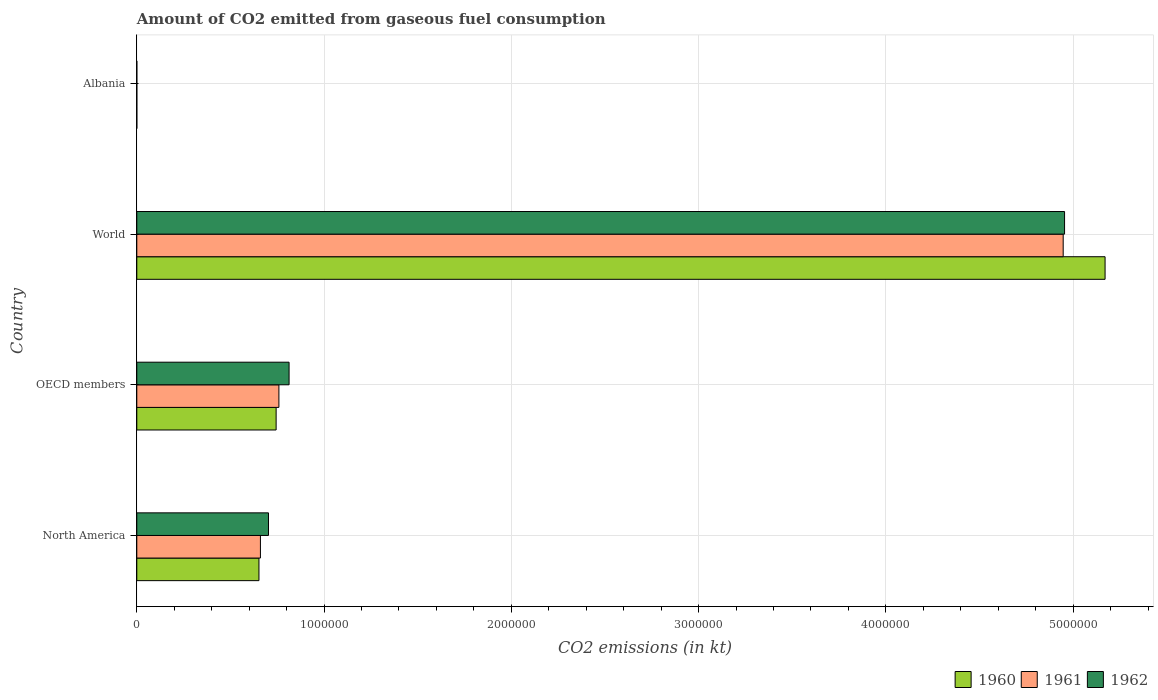How many different coloured bars are there?
Keep it short and to the point. 3. Are the number of bars per tick equal to the number of legend labels?
Give a very brief answer. Yes. What is the amount of CO2 emitted in 1962 in OECD members?
Provide a short and direct response. 8.13e+05. Across all countries, what is the maximum amount of CO2 emitted in 1962?
Give a very brief answer. 4.95e+06. Across all countries, what is the minimum amount of CO2 emitted in 1960?
Offer a very short reply. 84.34. In which country was the amount of CO2 emitted in 1960 minimum?
Offer a very short reply. Albania. What is the total amount of CO2 emitted in 1961 in the graph?
Your answer should be very brief. 6.37e+06. What is the difference between the amount of CO2 emitted in 1962 in Albania and that in OECD members?
Provide a short and direct response. -8.13e+05. What is the difference between the amount of CO2 emitted in 1960 in Albania and the amount of CO2 emitted in 1962 in North America?
Your answer should be very brief. -7.03e+05. What is the average amount of CO2 emitted in 1961 per country?
Make the answer very short. 1.59e+06. What is the difference between the amount of CO2 emitted in 1962 and amount of CO2 emitted in 1961 in North America?
Offer a terse response. 4.30e+04. What is the ratio of the amount of CO2 emitted in 1960 in Albania to that in North America?
Offer a very short reply. 0. Is the difference between the amount of CO2 emitted in 1962 in Albania and World greater than the difference between the amount of CO2 emitted in 1961 in Albania and World?
Ensure brevity in your answer.  No. What is the difference between the highest and the second highest amount of CO2 emitted in 1960?
Ensure brevity in your answer.  4.43e+06. What is the difference between the highest and the lowest amount of CO2 emitted in 1962?
Provide a succinct answer. 4.95e+06. What does the 3rd bar from the top in World represents?
Provide a short and direct response. 1960. What does the 2nd bar from the bottom in World represents?
Keep it short and to the point. 1961. How many bars are there?
Your response must be concise. 12. Are all the bars in the graph horizontal?
Your response must be concise. Yes. What is the difference between two consecutive major ticks on the X-axis?
Provide a short and direct response. 1.00e+06. Are the values on the major ticks of X-axis written in scientific E-notation?
Make the answer very short. No. Where does the legend appear in the graph?
Your answer should be compact. Bottom right. How many legend labels are there?
Offer a terse response. 3. How are the legend labels stacked?
Give a very brief answer. Horizontal. What is the title of the graph?
Your answer should be very brief. Amount of CO2 emitted from gaseous fuel consumption. Does "2014" appear as one of the legend labels in the graph?
Provide a short and direct response. No. What is the label or title of the X-axis?
Your answer should be very brief. CO2 emissions (in kt). What is the CO2 emissions (in kt) of 1960 in North America?
Provide a short and direct response. 6.52e+05. What is the CO2 emissions (in kt) of 1961 in North America?
Provide a succinct answer. 6.60e+05. What is the CO2 emissions (in kt) of 1962 in North America?
Ensure brevity in your answer.  7.03e+05. What is the CO2 emissions (in kt) in 1960 in OECD members?
Your response must be concise. 7.44e+05. What is the CO2 emissions (in kt) of 1961 in OECD members?
Ensure brevity in your answer.  7.59e+05. What is the CO2 emissions (in kt) in 1962 in OECD members?
Make the answer very short. 8.13e+05. What is the CO2 emissions (in kt) in 1960 in World?
Ensure brevity in your answer.  5.17e+06. What is the CO2 emissions (in kt) in 1961 in World?
Your answer should be compact. 4.95e+06. What is the CO2 emissions (in kt) of 1962 in World?
Make the answer very short. 4.95e+06. What is the CO2 emissions (in kt) of 1960 in Albania?
Your response must be concise. 84.34. What is the CO2 emissions (in kt) of 1961 in Albania?
Your answer should be compact. 84.34. What is the CO2 emissions (in kt) in 1962 in Albania?
Provide a succinct answer. 84.34. Across all countries, what is the maximum CO2 emissions (in kt) of 1960?
Provide a succinct answer. 5.17e+06. Across all countries, what is the maximum CO2 emissions (in kt) of 1961?
Make the answer very short. 4.95e+06. Across all countries, what is the maximum CO2 emissions (in kt) in 1962?
Ensure brevity in your answer.  4.95e+06. Across all countries, what is the minimum CO2 emissions (in kt) of 1960?
Keep it short and to the point. 84.34. Across all countries, what is the minimum CO2 emissions (in kt) of 1961?
Ensure brevity in your answer.  84.34. Across all countries, what is the minimum CO2 emissions (in kt) of 1962?
Give a very brief answer. 84.34. What is the total CO2 emissions (in kt) of 1960 in the graph?
Your answer should be compact. 6.57e+06. What is the total CO2 emissions (in kt) of 1961 in the graph?
Provide a succinct answer. 6.37e+06. What is the total CO2 emissions (in kt) in 1962 in the graph?
Keep it short and to the point. 6.47e+06. What is the difference between the CO2 emissions (in kt) in 1960 in North America and that in OECD members?
Keep it short and to the point. -9.17e+04. What is the difference between the CO2 emissions (in kt) of 1961 in North America and that in OECD members?
Your answer should be compact. -9.86e+04. What is the difference between the CO2 emissions (in kt) of 1962 in North America and that in OECD members?
Provide a short and direct response. -1.10e+05. What is the difference between the CO2 emissions (in kt) in 1960 in North America and that in World?
Ensure brevity in your answer.  -4.52e+06. What is the difference between the CO2 emissions (in kt) in 1961 in North America and that in World?
Your answer should be compact. -4.29e+06. What is the difference between the CO2 emissions (in kt) of 1962 in North America and that in World?
Keep it short and to the point. -4.25e+06. What is the difference between the CO2 emissions (in kt) in 1960 in North America and that in Albania?
Your response must be concise. 6.52e+05. What is the difference between the CO2 emissions (in kt) in 1961 in North America and that in Albania?
Offer a very short reply. 6.60e+05. What is the difference between the CO2 emissions (in kt) of 1962 in North America and that in Albania?
Make the answer very short. 7.03e+05. What is the difference between the CO2 emissions (in kt) in 1960 in OECD members and that in World?
Keep it short and to the point. -4.43e+06. What is the difference between the CO2 emissions (in kt) of 1961 in OECD members and that in World?
Provide a succinct answer. -4.19e+06. What is the difference between the CO2 emissions (in kt) in 1962 in OECD members and that in World?
Give a very brief answer. -4.14e+06. What is the difference between the CO2 emissions (in kt) of 1960 in OECD members and that in Albania?
Provide a short and direct response. 7.44e+05. What is the difference between the CO2 emissions (in kt) in 1961 in OECD members and that in Albania?
Give a very brief answer. 7.59e+05. What is the difference between the CO2 emissions (in kt) of 1962 in OECD members and that in Albania?
Ensure brevity in your answer.  8.13e+05. What is the difference between the CO2 emissions (in kt) in 1960 in World and that in Albania?
Your response must be concise. 5.17e+06. What is the difference between the CO2 emissions (in kt) in 1961 in World and that in Albania?
Give a very brief answer. 4.95e+06. What is the difference between the CO2 emissions (in kt) in 1962 in World and that in Albania?
Make the answer very short. 4.95e+06. What is the difference between the CO2 emissions (in kt) of 1960 in North America and the CO2 emissions (in kt) of 1961 in OECD members?
Your answer should be compact. -1.06e+05. What is the difference between the CO2 emissions (in kt) in 1960 in North America and the CO2 emissions (in kt) in 1962 in OECD members?
Keep it short and to the point. -1.61e+05. What is the difference between the CO2 emissions (in kt) of 1961 in North America and the CO2 emissions (in kt) of 1962 in OECD members?
Offer a terse response. -1.53e+05. What is the difference between the CO2 emissions (in kt) in 1960 in North America and the CO2 emissions (in kt) in 1961 in World?
Provide a succinct answer. -4.29e+06. What is the difference between the CO2 emissions (in kt) in 1960 in North America and the CO2 emissions (in kt) in 1962 in World?
Provide a short and direct response. -4.30e+06. What is the difference between the CO2 emissions (in kt) in 1961 in North America and the CO2 emissions (in kt) in 1962 in World?
Make the answer very short. -4.29e+06. What is the difference between the CO2 emissions (in kt) of 1960 in North America and the CO2 emissions (in kt) of 1961 in Albania?
Offer a terse response. 6.52e+05. What is the difference between the CO2 emissions (in kt) in 1960 in North America and the CO2 emissions (in kt) in 1962 in Albania?
Keep it short and to the point. 6.52e+05. What is the difference between the CO2 emissions (in kt) of 1961 in North America and the CO2 emissions (in kt) of 1962 in Albania?
Offer a very short reply. 6.60e+05. What is the difference between the CO2 emissions (in kt) of 1960 in OECD members and the CO2 emissions (in kt) of 1961 in World?
Keep it short and to the point. -4.20e+06. What is the difference between the CO2 emissions (in kt) in 1960 in OECD members and the CO2 emissions (in kt) in 1962 in World?
Your response must be concise. -4.21e+06. What is the difference between the CO2 emissions (in kt) in 1961 in OECD members and the CO2 emissions (in kt) in 1962 in World?
Make the answer very short. -4.20e+06. What is the difference between the CO2 emissions (in kt) of 1960 in OECD members and the CO2 emissions (in kt) of 1961 in Albania?
Offer a terse response. 7.44e+05. What is the difference between the CO2 emissions (in kt) in 1960 in OECD members and the CO2 emissions (in kt) in 1962 in Albania?
Make the answer very short. 7.44e+05. What is the difference between the CO2 emissions (in kt) of 1961 in OECD members and the CO2 emissions (in kt) of 1962 in Albania?
Your answer should be very brief. 7.59e+05. What is the difference between the CO2 emissions (in kt) of 1960 in World and the CO2 emissions (in kt) of 1961 in Albania?
Your answer should be compact. 5.17e+06. What is the difference between the CO2 emissions (in kt) in 1960 in World and the CO2 emissions (in kt) in 1962 in Albania?
Your answer should be very brief. 5.17e+06. What is the difference between the CO2 emissions (in kt) in 1961 in World and the CO2 emissions (in kt) in 1962 in Albania?
Your answer should be very brief. 4.95e+06. What is the average CO2 emissions (in kt) of 1960 per country?
Your response must be concise. 1.64e+06. What is the average CO2 emissions (in kt) of 1961 per country?
Ensure brevity in your answer.  1.59e+06. What is the average CO2 emissions (in kt) of 1962 per country?
Give a very brief answer. 1.62e+06. What is the difference between the CO2 emissions (in kt) of 1960 and CO2 emissions (in kt) of 1961 in North America?
Your answer should be very brief. -7828.66. What is the difference between the CO2 emissions (in kt) in 1960 and CO2 emissions (in kt) in 1962 in North America?
Provide a succinct answer. -5.08e+04. What is the difference between the CO2 emissions (in kt) of 1961 and CO2 emissions (in kt) of 1962 in North America?
Give a very brief answer. -4.30e+04. What is the difference between the CO2 emissions (in kt) of 1960 and CO2 emissions (in kt) of 1961 in OECD members?
Provide a succinct answer. -1.48e+04. What is the difference between the CO2 emissions (in kt) of 1960 and CO2 emissions (in kt) of 1962 in OECD members?
Give a very brief answer. -6.92e+04. What is the difference between the CO2 emissions (in kt) of 1961 and CO2 emissions (in kt) of 1962 in OECD members?
Offer a very short reply. -5.44e+04. What is the difference between the CO2 emissions (in kt) in 1960 and CO2 emissions (in kt) in 1961 in World?
Your answer should be very brief. 2.24e+05. What is the difference between the CO2 emissions (in kt) of 1960 and CO2 emissions (in kt) of 1962 in World?
Keep it short and to the point. 2.16e+05. What is the difference between the CO2 emissions (in kt) of 1961 and CO2 emissions (in kt) of 1962 in World?
Offer a terse response. -7334. What is the difference between the CO2 emissions (in kt) of 1960 and CO2 emissions (in kt) of 1962 in Albania?
Offer a very short reply. 0. What is the difference between the CO2 emissions (in kt) of 1961 and CO2 emissions (in kt) of 1962 in Albania?
Provide a succinct answer. 0. What is the ratio of the CO2 emissions (in kt) of 1960 in North America to that in OECD members?
Your answer should be compact. 0.88. What is the ratio of the CO2 emissions (in kt) in 1961 in North America to that in OECD members?
Make the answer very short. 0.87. What is the ratio of the CO2 emissions (in kt) of 1962 in North America to that in OECD members?
Your answer should be very brief. 0.86. What is the ratio of the CO2 emissions (in kt) in 1960 in North America to that in World?
Your answer should be compact. 0.13. What is the ratio of the CO2 emissions (in kt) of 1961 in North America to that in World?
Offer a very short reply. 0.13. What is the ratio of the CO2 emissions (in kt) of 1962 in North America to that in World?
Provide a succinct answer. 0.14. What is the ratio of the CO2 emissions (in kt) in 1960 in North America to that in Albania?
Provide a short and direct response. 7734.89. What is the ratio of the CO2 emissions (in kt) of 1961 in North America to that in Albania?
Your answer should be compact. 7827.72. What is the ratio of the CO2 emissions (in kt) of 1962 in North America to that in Albania?
Your answer should be compact. 8337.76. What is the ratio of the CO2 emissions (in kt) in 1960 in OECD members to that in World?
Keep it short and to the point. 0.14. What is the ratio of the CO2 emissions (in kt) in 1961 in OECD members to that in World?
Provide a succinct answer. 0.15. What is the ratio of the CO2 emissions (in kt) in 1962 in OECD members to that in World?
Provide a short and direct response. 0.16. What is the ratio of the CO2 emissions (in kt) of 1960 in OECD members to that in Albania?
Your response must be concise. 8821.78. What is the ratio of the CO2 emissions (in kt) in 1961 in OECD members to that in Albania?
Offer a terse response. 8997.23. What is the ratio of the CO2 emissions (in kt) of 1962 in OECD members to that in Albania?
Provide a succinct answer. 9641.88. What is the ratio of the CO2 emissions (in kt) of 1960 in World to that in Albania?
Your response must be concise. 6.13e+04. What is the ratio of the CO2 emissions (in kt) in 1961 in World to that in Albania?
Your answer should be compact. 5.87e+04. What is the ratio of the CO2 emissions (in kt) in 1962 in World to that in Albania?
Provide a succinct answer. 5.87e+04. What is the difference between the highest and the second highest CO2 emissions (in kt) in 1960?
Ensure brevity in your answer.  4.43e+06. What is the difference between the highest and the second highest CO2 emissions (in kt) in 1961?
Your answer should be very brief. 4.19e+06. What is the difference between the highest and the second highest CO2 emissions (in kt) in 1962?
Offer a terse response. 4.14e+06. What is the difference between the highest and the lowest CO2 emissions (in kt) of 1960?
Give a very brief answer. 5.17e+06. What is the difference between the highest and the lowest CO2 emissions (in kt) of 1961?
Keep it short and to the point. 4.95e+06. What is the difference between the highest and the lowest CO2 emissions (in kt) of 1962?
Give a very brief answer. 4.95e+06. 